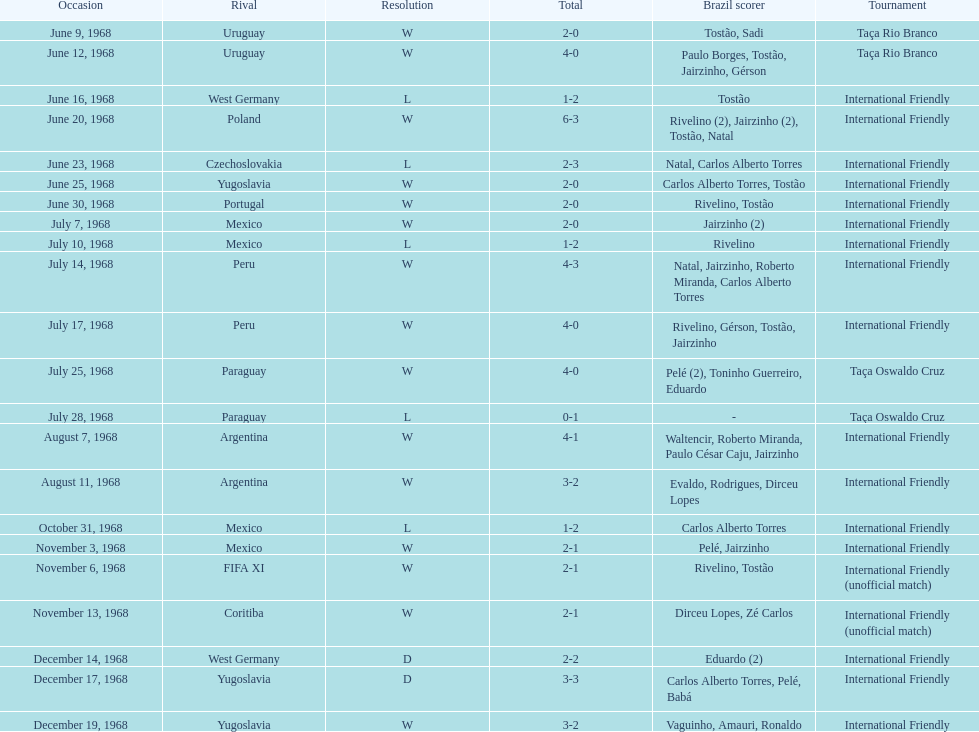How many times did brazil play against argentina in the international friendly competition? 2. 